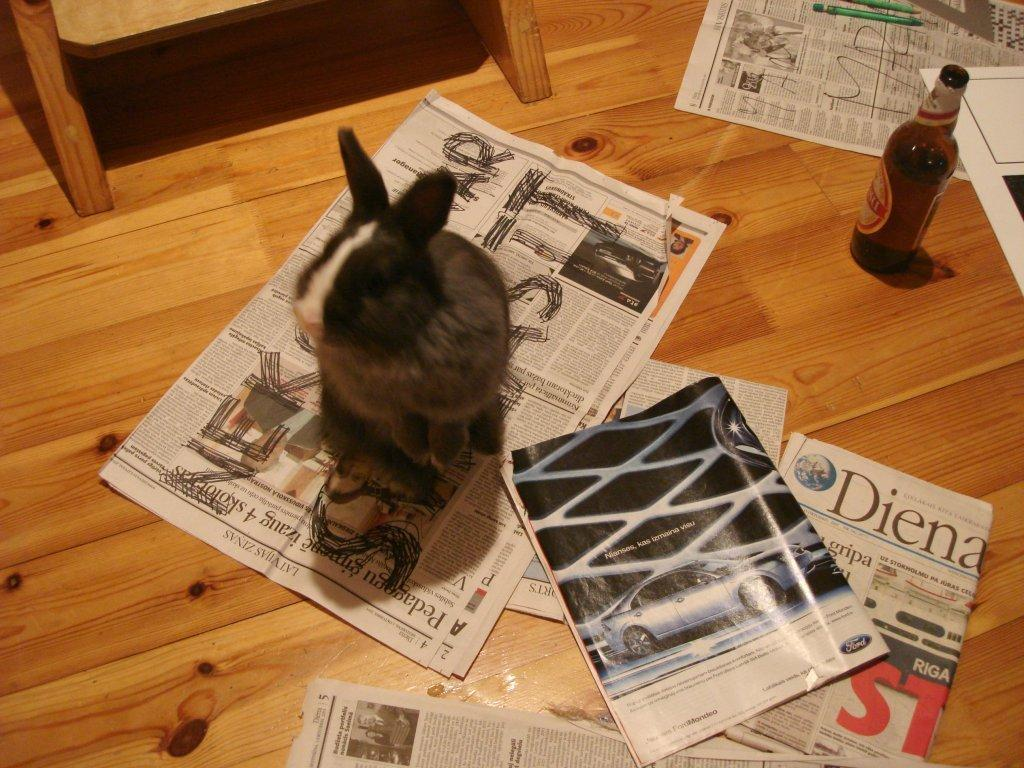What type of animal can be seen in the image? There is an animal in the image, but its specific type is not mentioned in the facts. What is the animal sitting on? The animal is sitting on a newspaper. What other objects are present in the image? There is a bottle, a magazine, and a pen in the image. What flavor of ice cream does the animal prefer in the image? There is no mention of ice cream or any flavor preferences in the image or the provided facts. 